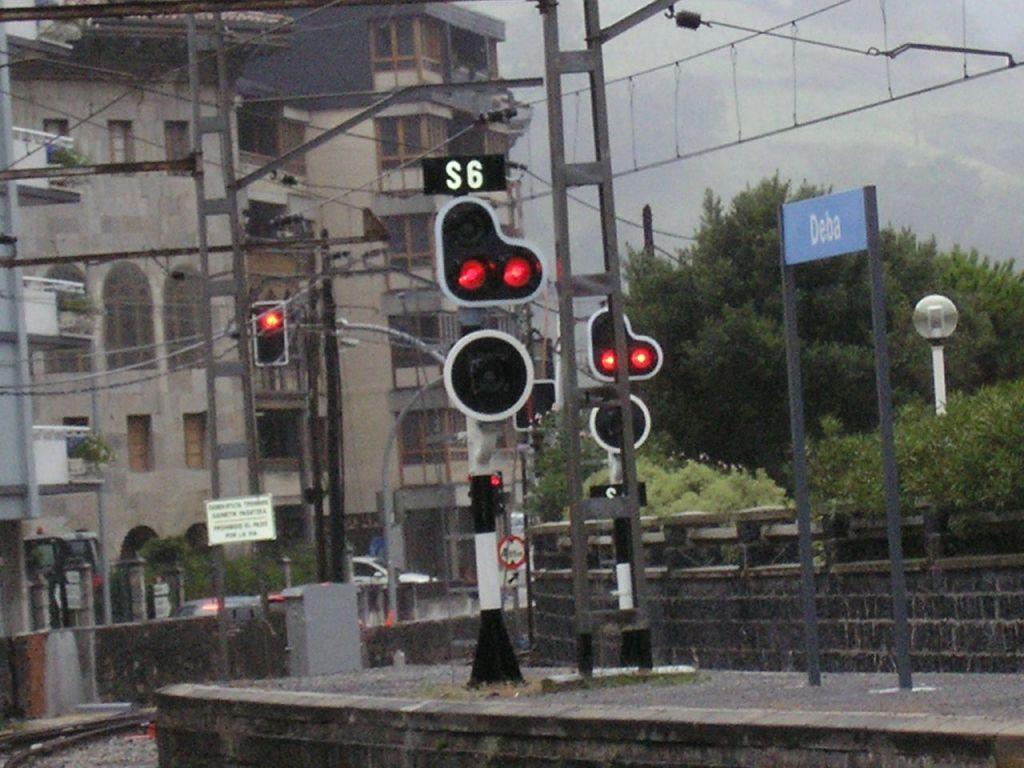What stop light number is this?
Make the answer very short. S6. What does the sign to the right of the red lights say?
Provide a short and direct response. Deba. 